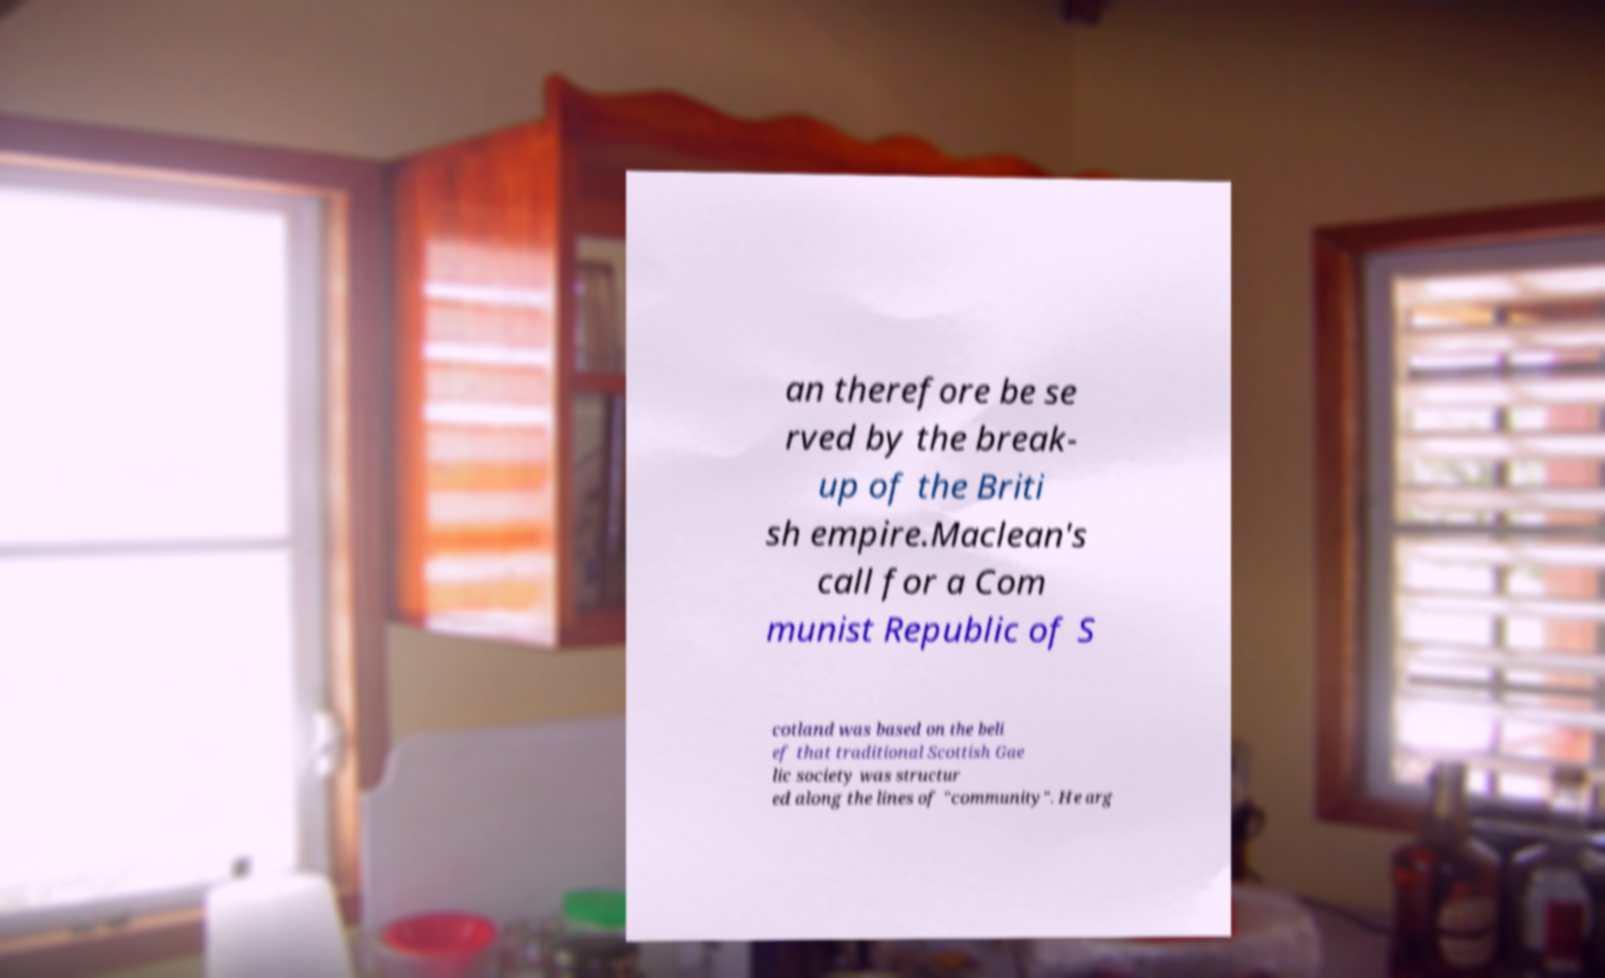Can you accurately transcribe the text from the provided image for me? an therefore be se rved by the break- up of the Briti sh empire.Maclean's call for a Com munist Republic of S cotland was based on the beli ef that traditional Scottish Gae lic society was structur ed along the lines of "community". He arg 